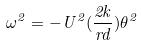Convert formula to latex. <formula><loc_0><loc_0><loc_500><loc_500>\omega ^ { 2 } = - U ^ { 2 } ( \frac { 2 k } { r d } ) \theta ^ { 2 }</formula> 